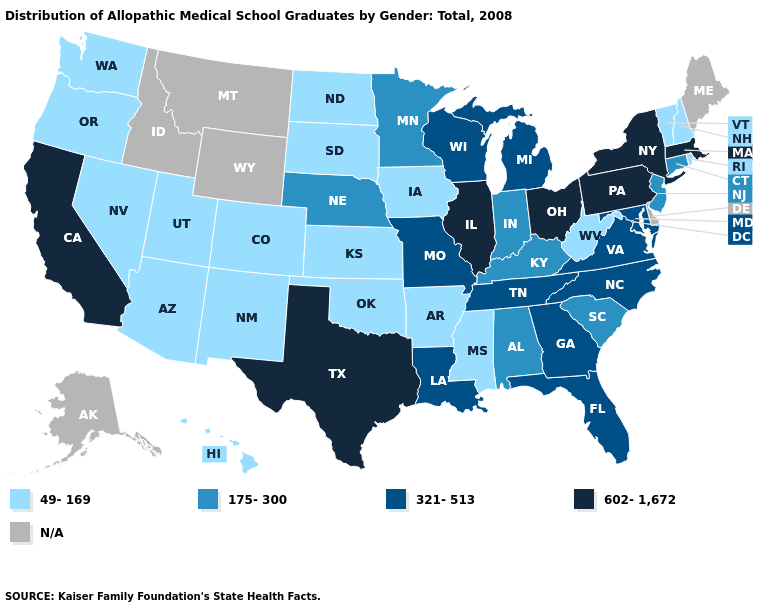Does the map have missing data?
Write a very short answer. Yes. Does the first symbol in the legend represent the smallest category?
Keep it brief. Yes. Does the map have missing data?
Quick response, please. Yes. Which states have the lowest value in the USA?
Be succinct. Arizona, Arkansas, Colorado, Hawaii, Iowa, Kansas, Mississippi, Nevada, New Hampshire, New Mexico, North Dakota, Oklahoma, Oregon, Rhode Island, South Dakota, Utah, Vermont, Washington, West Virginia. What is the lowest value in the MidWest?
Keep it brief. 49-169. Which states have the highest value in the USA?
Answer briefly. California, Illinois, Massachusetts, New York, Ohio, Pennsylvania, Texas. Name the states that have a value in the range 602-1,672?
Answer briefly. California, Illinois, Massachusetts, New York, Ohio, Pennsylvania, Texas. What is the value of Colorado?
Give a very brief answer. 49-169. Among the states that border Kentucky , which have the highest value?
Write a very short answer. Illinois, Ohio. Which states have the lowest value in the MidWest?
Concise answer only. Iowa, Kansas, North Dakota, South Dakota. Name the states that have a value in the range 175-300?
Answer briefly. Alabama, Connecticut, Indiana, Kentucky, Minnesota, Nebraska, New Jersey, South Carolina. Is the legend a continuous bar?
Give a very brief answer. No. What is the value of Massachusetts?
Be succinct. 602-1,672. What is the value of South Carolina?
Concise answer only. 175-300. 